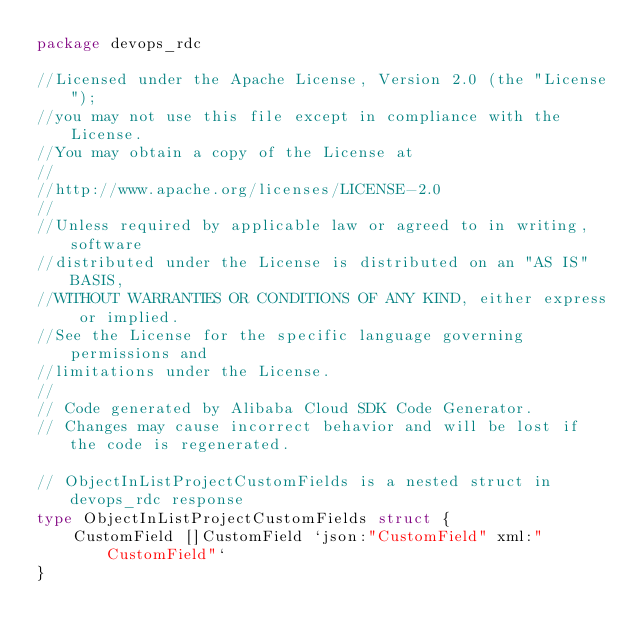Convert code to text. <code><loc_0><loc_0><loc_500><loc_500><_Go_>package devops_rdc

//Licensed under the Apache License, Version 2.0 (the "License");
//you may not use this file except in compliance with the License.
//You may obtain a copy of the License at
//
//http://www.apache.org/licenses/LICENSE-2.0
//
//Unless required by applicable law or agreed to in writing, software
//distributed under the License is distributed on an "AS IS" BASIS,
//WITHOUT WARRANTIES OR CONDITIONS OF ANY KIND, either express or implied.
//See the License for the specific language governing permissions and
//limitations under the License.
//
// Code generated by Alibaba Cloud SDK Code Generator.
// Changes may cause incorrect behavior and will be lost if the code is regenerated.

// ObjectInListProjectCustomFields is a nested struct in devops_rdc response
type ObjectInListProjectCustomFields struct {
	CustomField []CustomField `json:"CustomField" xml:"CustomField"`
}
</code> 